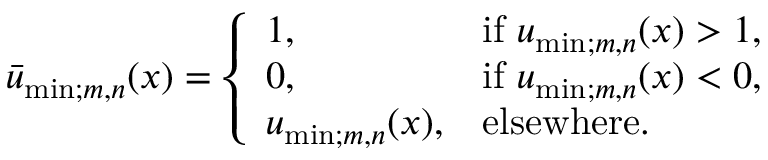<formula> <loc_0><loc_0><loc_500><loc_500>\begin{array} { r } { \bar { u } _ { \min ; m , n } ( x ) = \left \{ \begin{array} { l l } { 1 , \quad } & { i f u _ { \min ; m , n } ( x ) > 1 , } \\ { 0 , } & { i f u _ { \min ; m , n } ( x ) < 0 , } \\ { u _ { \min ; m , n } ( x ) , } & { e l s e w h e r e . } \end{array} } \end{array}</formula> 